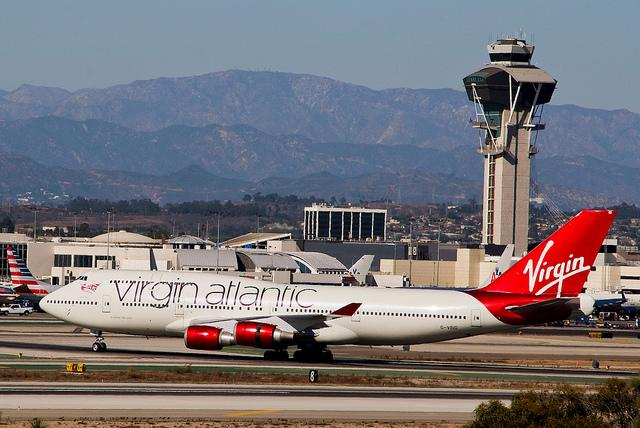Who owns the company whose name appears here?

Choices:
A) eli whitney
B) richard branson
C) juan borgia
D) will smith richard branson 